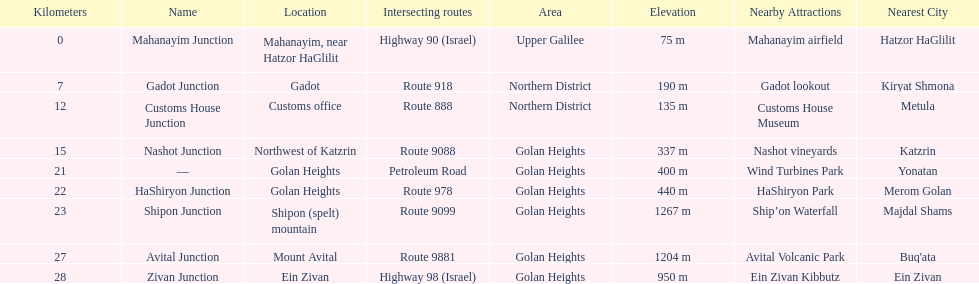What junction is the furthest from mahanayim junction? Zivan Junction. 